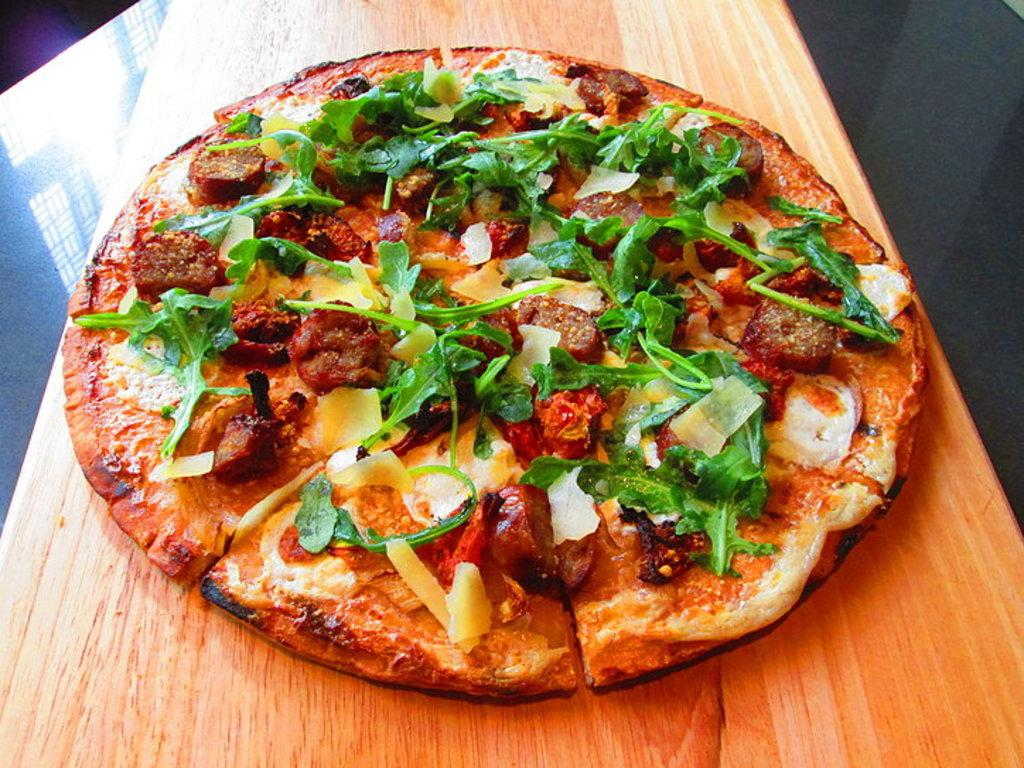What is the main object in the image? There is a wooden plank in the image. What is on top of the wooden plank? The wooden plank has a pizza on it. What kind of toppings are on the pizza? The pizza is topped with leaves and food. Where is the wooden plank placed? The wooden plank is placed on a stone slab. Can you see any twigs or lace in the image? No, there are no twigs or lace present in the image. 